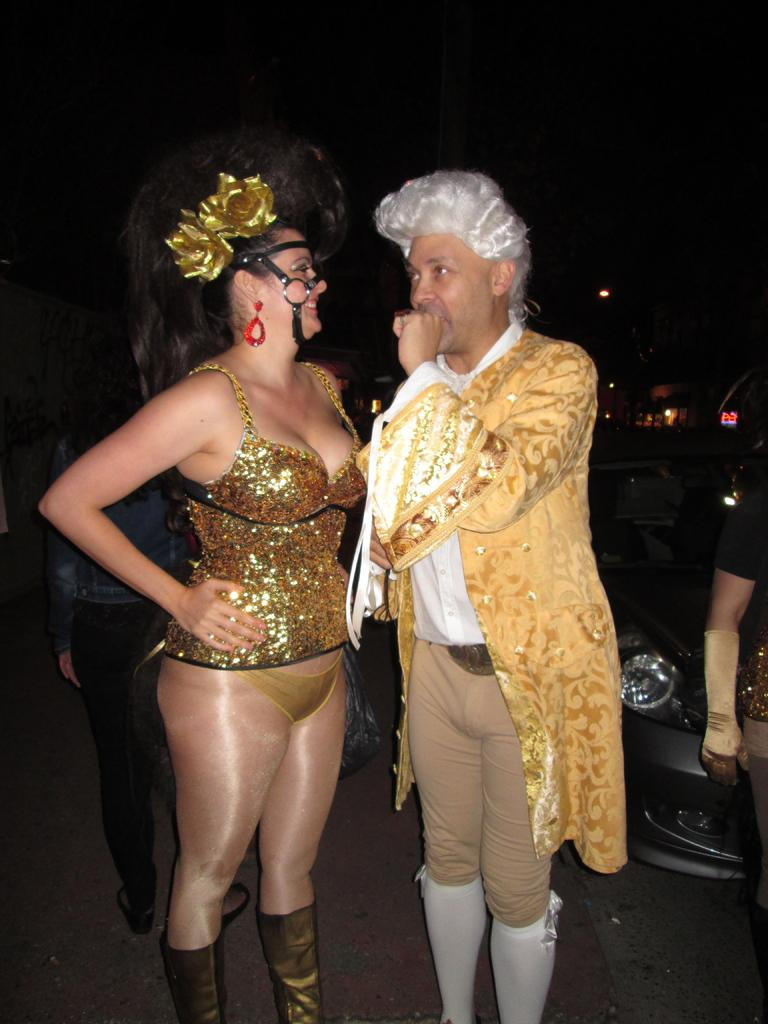How many people are present in the image? There are three people in the image, a man, a woman, and another person behind them. What are the man and woman doing in the image? The man and woman are standing and wearing costumes. What can be seen to the right of the image? There is a car to the right of the image. What is the lighting condition in the image? The background of the image is dark. What type of ink is being used by the man in the image? There is no ink present in the image, as the man and woman are wearing costumes and not engaging in any activity that would involve ink. 